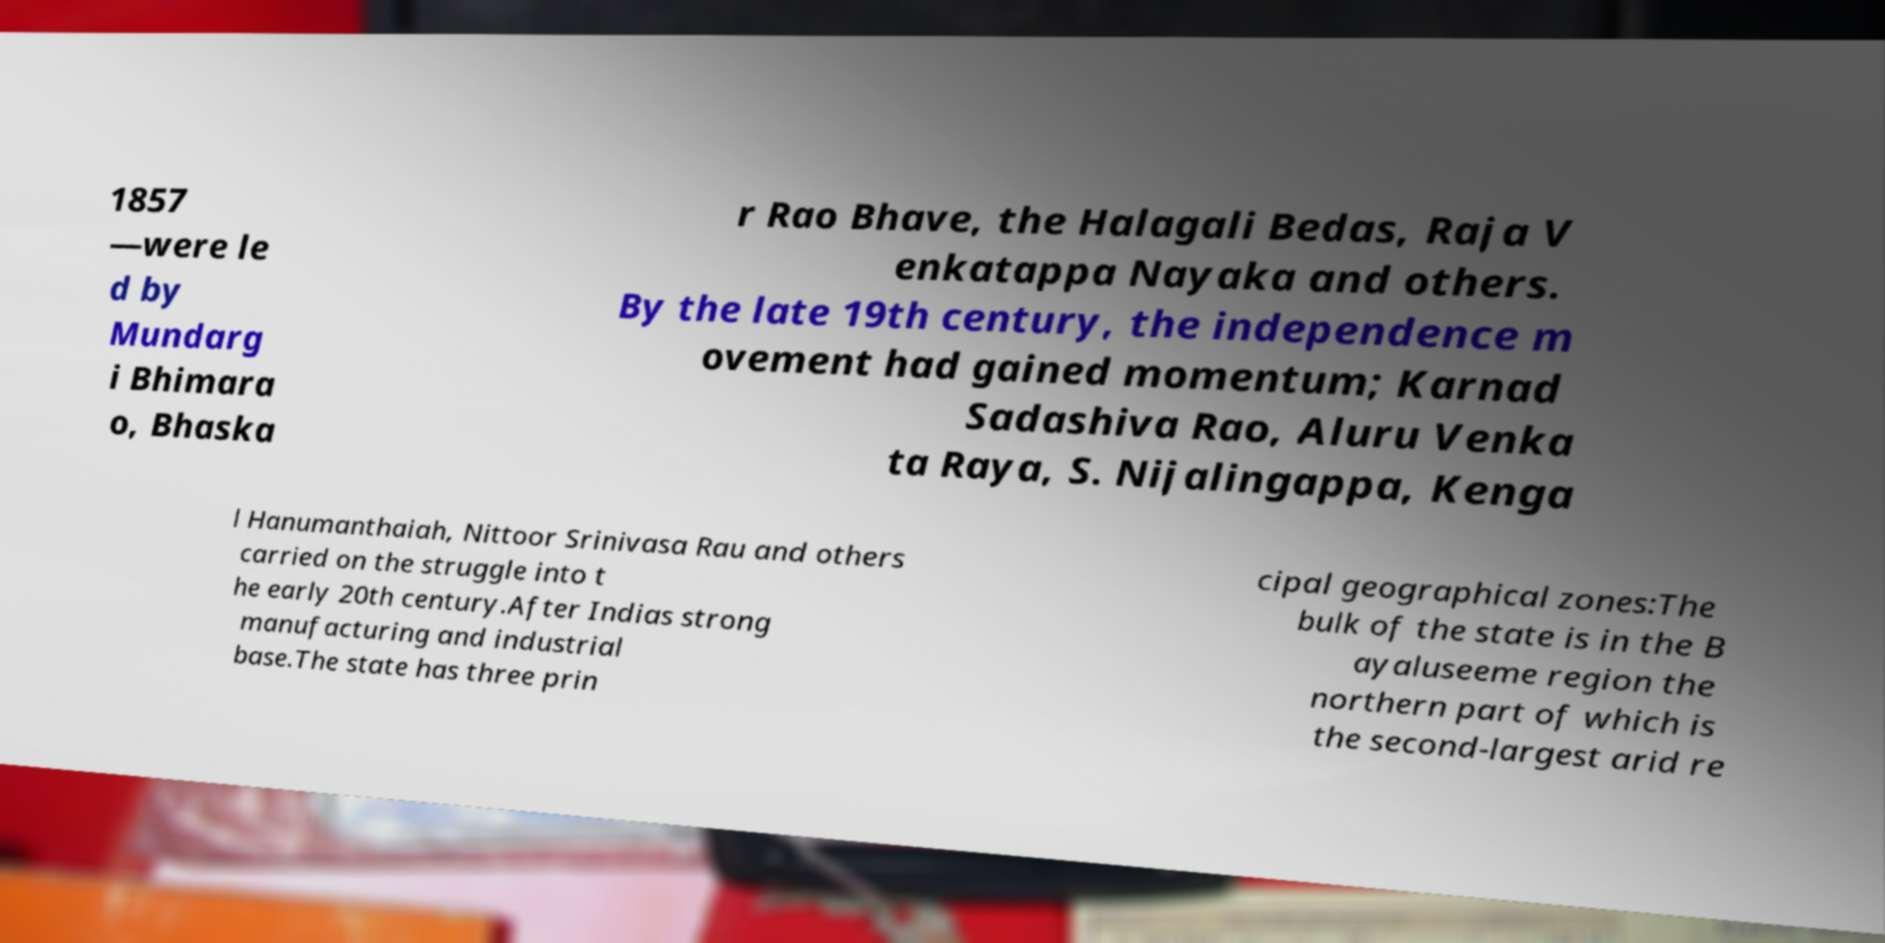I need the written content from this picture converted into text. Can you do that? 1857 —were le d by Mundarg i Bhimara o, Bhaska r Rao Bhave, the Halagali Bedas, Raja V enkatappa Nayaka and others. By the late 19th century, the independence m ovement had gained momentum; Karnad Sadashiva Rao, Aluru Venka ta Raya, S. Nijalingappa, Kenga l Hanumanthaiah, Nittoor Srinivasa Rau and others carried on the struggle into t he early 20th century.After Indias strong manufacturing and industrial base.The state has three prin cipal geographical zones:The bulk of the state is in the B ayaluseeme region the northern part of which is the second-largest arid re 